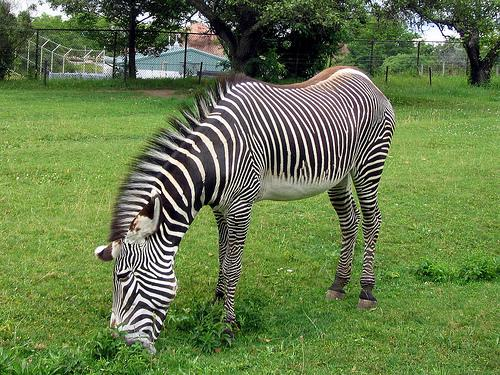Question: who is the subject of the photo?
Choices:
A. The zebra.
B. The giraffe.
C. The lion.
D. The elephant.
Answer with the letter. Answer: A Question: where is the zebra?
Choices:
A. In a cage.
B. In the dirt.
C. In the grass.
D. By the trees.
Answer with the letter. Answer: C Question: why is the photo illuminated?
Choices:
A. Flash light.
B. Camera bulb.
C. Tv ligh.
D. Sunlight.
Answer with the letter. Answer: D Question: what color are the hooves?
Choices:
A. Brown.
B. White.
C. Silver.
D. Black.
Answer with the letter. Answer: D 